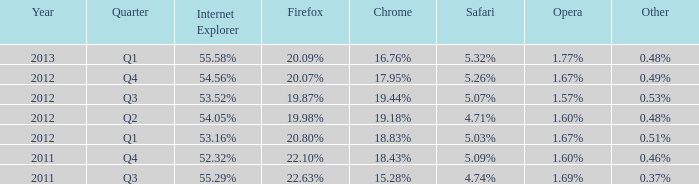What internet explorer has 1.67% as the opera, with 2012 q1 as the period? 53.16%. 